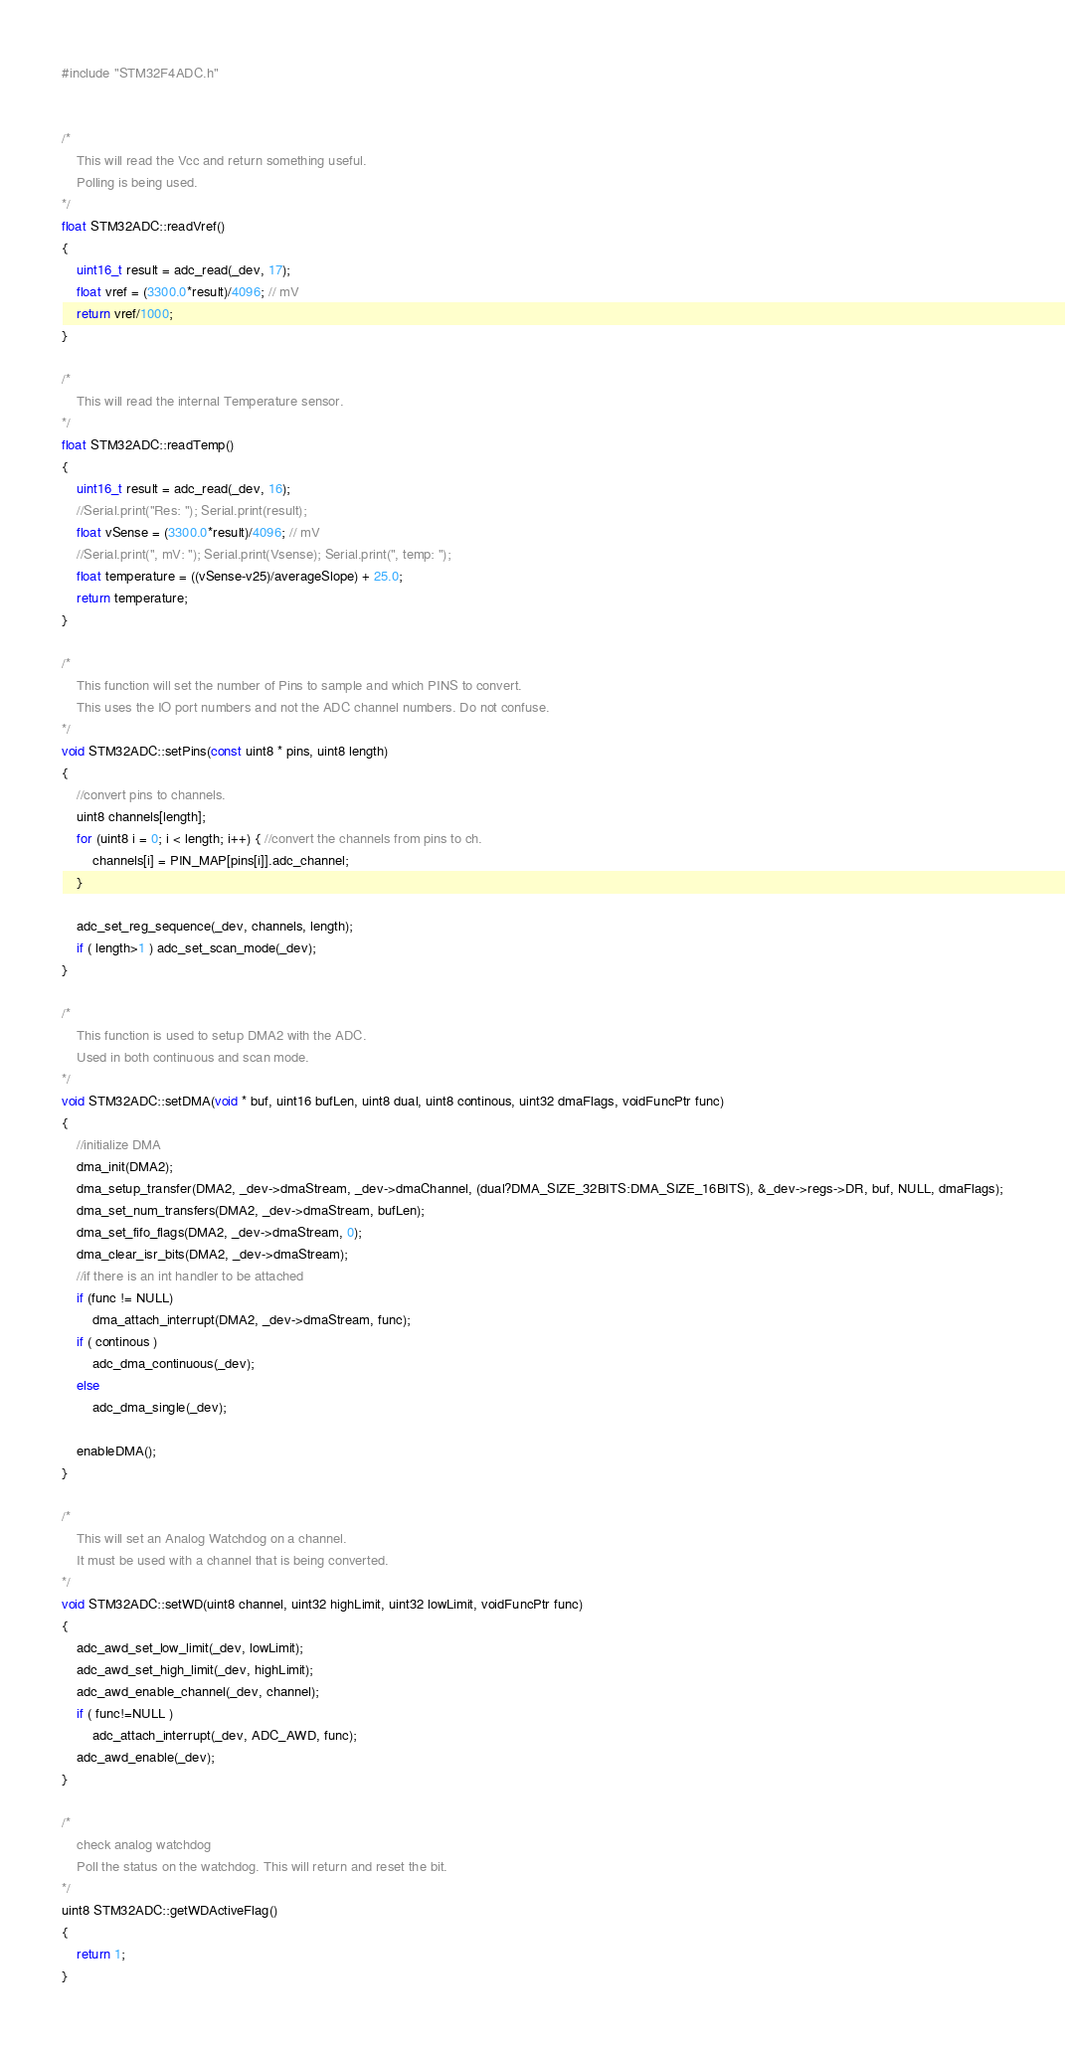Convert code to text. <code><loc_0><loc_0><loc_500><loc_500><_C++_>#include "STM32F4ADC.h"


/*
    This will read the Vcc and return something useful.
    Polling is being used.
*/
float STM32ADC::readVref()
{
    uint16_t result = adc_read(_dev, 17);
    float vref = (3300.0*result)/4096; // mV
    return vref/1000;
}

/*
    This will read the internal Temperature sensor.
*/
float STM32ADC::readTemp()
{
    uint16_t result = adc_read(_dev, 16);
    //Serial.print("Res: "); Serial.print(result);
    float vSense = (3300.0*result)/4096; // mV
    //Serial.print(", mV: "); Serial.print(Vsense); Serial.print(", temp: ");
    float temperature = ((vSense-v25)/averageSlope) + 25.0; 
    return temperature;
}

/*
    This function will set the number of Pins to sample and which PINS to convert. 
    This uses the IO port numbers and not the ADC channel numbers. Do not confuse. 
*/
void STM32ADC::setPins(const uint8 * pins, uint8 length)
{
    //convert pins to channels.
    uint8 channels[length];
    for (uint8 i = 0; i < length; i++) { //convert the channels from pins to ch.
        channels[i] = PIN_MAP[pins[i]].adc_channel;
    }

    adc_set_reg_sequence(_dev, channels, length);
    if ( length>1 ) adc_set_scan_mode(_dev);
}

/*
    This function is used to setup DMA2 with the ADC. 
    Used in both continuous and scan mode. 
*/
void STM32ADC::setDMA(void * buf, uint16 bufLen, uint8 dual, uint8 continous, uint32 dmaFlags, voidFuncPtr func)
{
    //initialize DMA
    dma_init(DMA2);
    dma_setup_transfer(DMA2, _dev->dmaStream, _dev->dmaChannel, (dual?DMA_SIZE_32BITS:DMA_SIZE_16BITS), &_dev->regs->DR, buf, NULL, dmaFlags);
    dma_set_num_transfers(DMA2, _dev->dmaStream, bufLen);
    dma_set_fifo_flags(DMA2, _dev->dmaStream, 0);
    dma_clear_isr_bits(DMA2, _dev->dmaStream);
    //if there is an int handler to be attached
    if (func != NULL)
        dma_attach_interrupt(DMA2, _dev->dmaStream, func);
    if ( continous )
        adc_dma_continuous(_dev);
    else
        adc_dma_single(_dev);

    enableDMA();
}

/*
    This will set an Analog Watchdog on a channel.
    It must be used with a channel that is being converted.
*/
void STM32ADC::setWD(uint8 channel, uint32 highLimit, uint32 lowLimit, voidFuncPtr func)
{
    adc_awd_set_low_limit(_dev, lowLimit);
    adc_awd_set_high_limit(_dev, highLimit);
    adc_awd_enable_channel(_dev, channel);
    if ( func!=NULL )
        adc_attach_interrupt(_dev, ADC_AWD, func);
    adc_awd_enable(_dev);
}

/*
    check analog watchdog
    Poll the status on the watchdog. This will return and reset the bit.
*/
uint8 STM32ADC::getWDActiveFlag()
{
    return 1;
}
</code> 